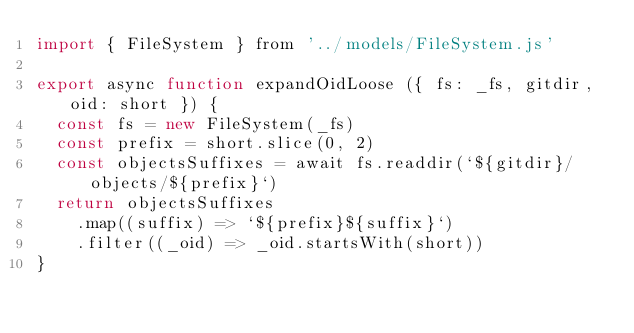Convert code to text. <code><loc_0><loc_0><loc_500><loc_500><_JavaScript_>import { FileSystem } from '../models/FileSystem.js'

export async function expandOidLoose ({ fs: _fs, gitdir, oid: short }) {
  const fs = new FileSystem(_fs)
  const prefix = short.slice(0, 2)
  const objectsSuffixes = await fs.readdir(`${gitdir}/objects/${prefix}`)
  return objectsSuffixes
    .map((suffix) => `${prefix}${suffix}`)
    .filter((_oid) => _oid.startsWith(short))
}
</code> 